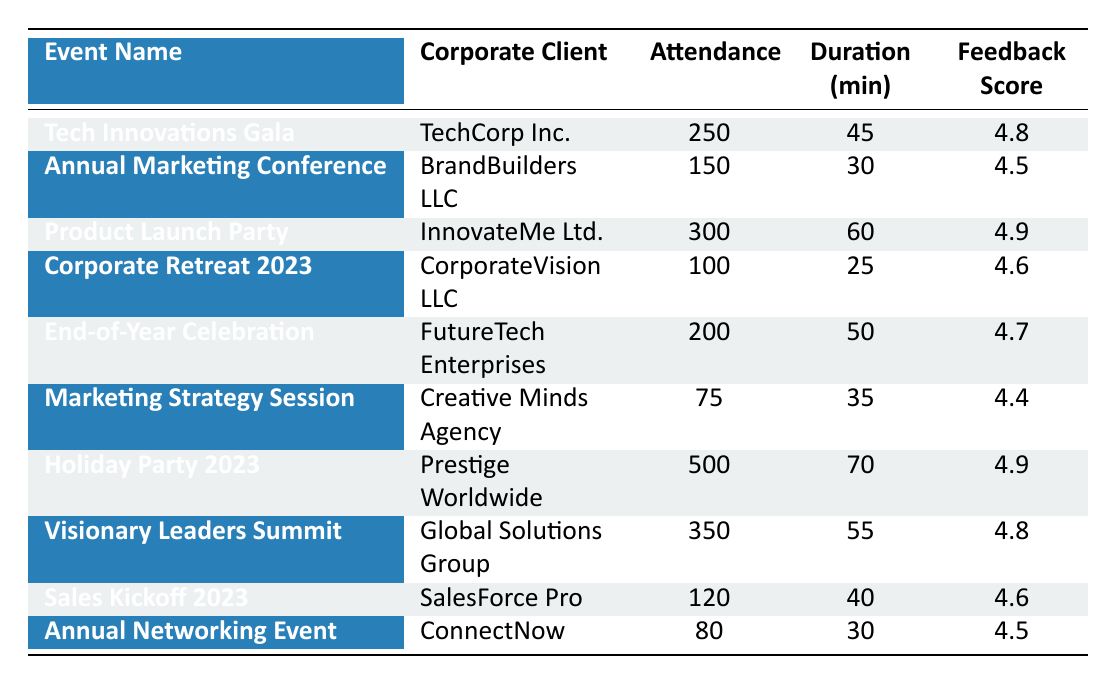What is the highest attendance recorded in the table? The highest attendance in the table can be found by looking through the "Attendance" column. The values are: 250, 150, 300, 100, 200, 75, 500, 350, 120, and 80. The maximum value is 500.
Answer: 500 Which corporate client had the longest show duration? To find the longest show duration, we examine the "Duration (min)" column. The durations listed are: 45, 30, 60, 25, 50, 35, 70, 55, 40, and 30. The maximum duration is 70 minutes, which corresponds to the "Holiday Party 2023" event organized by "Prestige Worldwide."
Answer: Prestige Worldwide What is the average audience feedback score for all events? The audience feedback scores listed are: 4.8, 4.5, 4.9, 4.6, 4.7, 4.4, 4.9, 4.8, 4.6, and 4.5. Summing these values gives 4.8 + 4.5 + 4.9 + 4.6 + 4.7 + 4.4 + 4.9 + 4.8 + 4.6 + 4.5 = 46.6. There are 10 events, so the average is 46.6 / 10 = 4.66.
Answer: 4.66 Were there any events with an attendance of less than 100? By looking at the "Attendance" column, the values are checked: 250, 150, 300, 100, 200, 75, 500, 350, 120, and 80. The numbers less than 100 are 75 and 80. Therefore, there were such events.
Answer: Yes What is the difference in attendance between the "Tech Innovations Gala" and "Holiday Party 2023"? The attendance for "Tech Innovations Gala" is 250 and for "Holiday Party 2023" is 500. To find the difference, we subtract: 500 - 250 = 250.
Answer: 250 How many events took place in San Francisco? Scanning the "Location" column for entries, the only event listed in San Francisco is the "End-of-Year Celebration." Thus, there is one event in this location.
Answer: 1 What percentage of events scored above 4.7 in audience feedback? The scores above 4.7 are from "Tech Innovations Gala" (4.8), "Product Launch Party" (4.9), "Holiday Party 2023" (4.9), and "Visionary Leaders Summit" (4.8). There are 4 events out of 10 total events. Therefore, the percentage is (4 / 10) * 100 = 40%.
Answer: 40% Is there any event that took place in Los Angeles? Checking the "Location" column, the "Annual Marketing Conference" is the only event held in Los Angeles. Thus, there is indeed an event in this city.
Answer: Yes Which event had the lowest feedback score? Reviewing the "Feedback Score" column, the scores are: 4.8, 4.5, 4.9, 4.6, 4.7, 4.4, 4.9, 4.8, 4.6, and 4.5. The lowest score is 4.4, which corresponds to the "Marketing Strategy Session."
Answer: Marketing Strategy Session What is the total attendance across all events listed? The attendance numbers are summed up: 250 + 150 + 300 + 100 + 200 + 75 + 500 + 350 + 120 + 80 = 2125. Thus, the total attendance is 2125.
Answer: 2125 